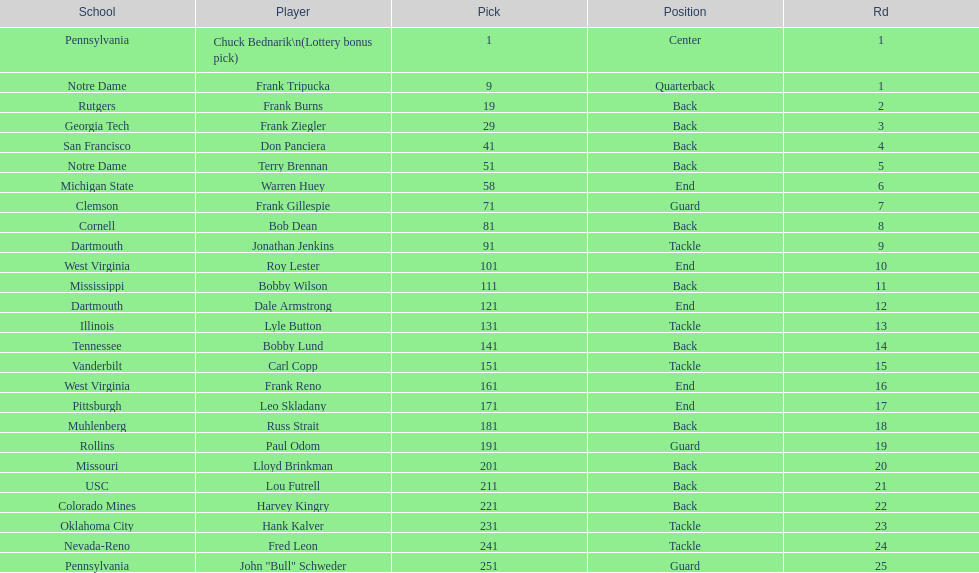Who was selected following roy lester? Bobby Wilson. 